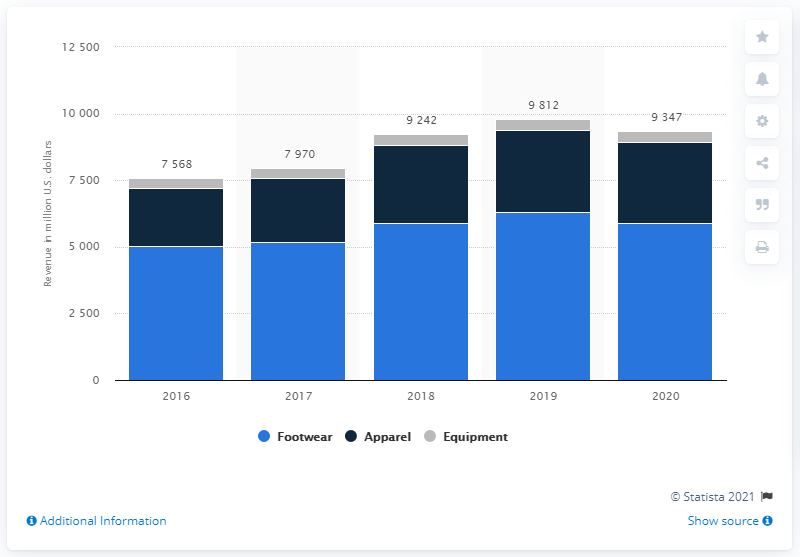Give some essential details in this illustration. In 2020, the apparel and equipment segments of Nike generated a total revenue of approximately $402 million. In 2020, Nike's footwear revenue from the EMEA region was $58,920. 